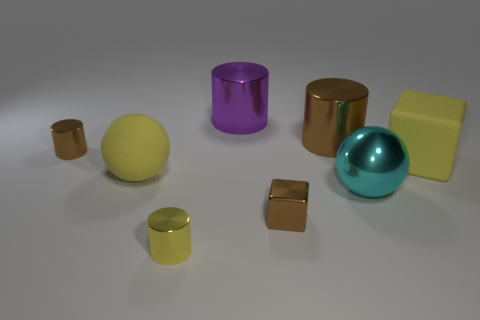Subtract all purple cylinders. How many cylinders are left? 3 Subtract 2 cylinders. How many cylinders are left? 2 Subtract all red cylinders. Subtract all cyan balls. How many cylinders are left? 4 Add 2 cubes. How many objects exist? 10 Add 2 brown things. How many brown things exist? 5 Subtract 1 cyan balls. How many objects are left? 7 Subtract all small metal cylinders. Subtract all large cyan things. How many objects are left? 5 Add 3 small shiny cubes. How many small shiny cubes are left? 4 